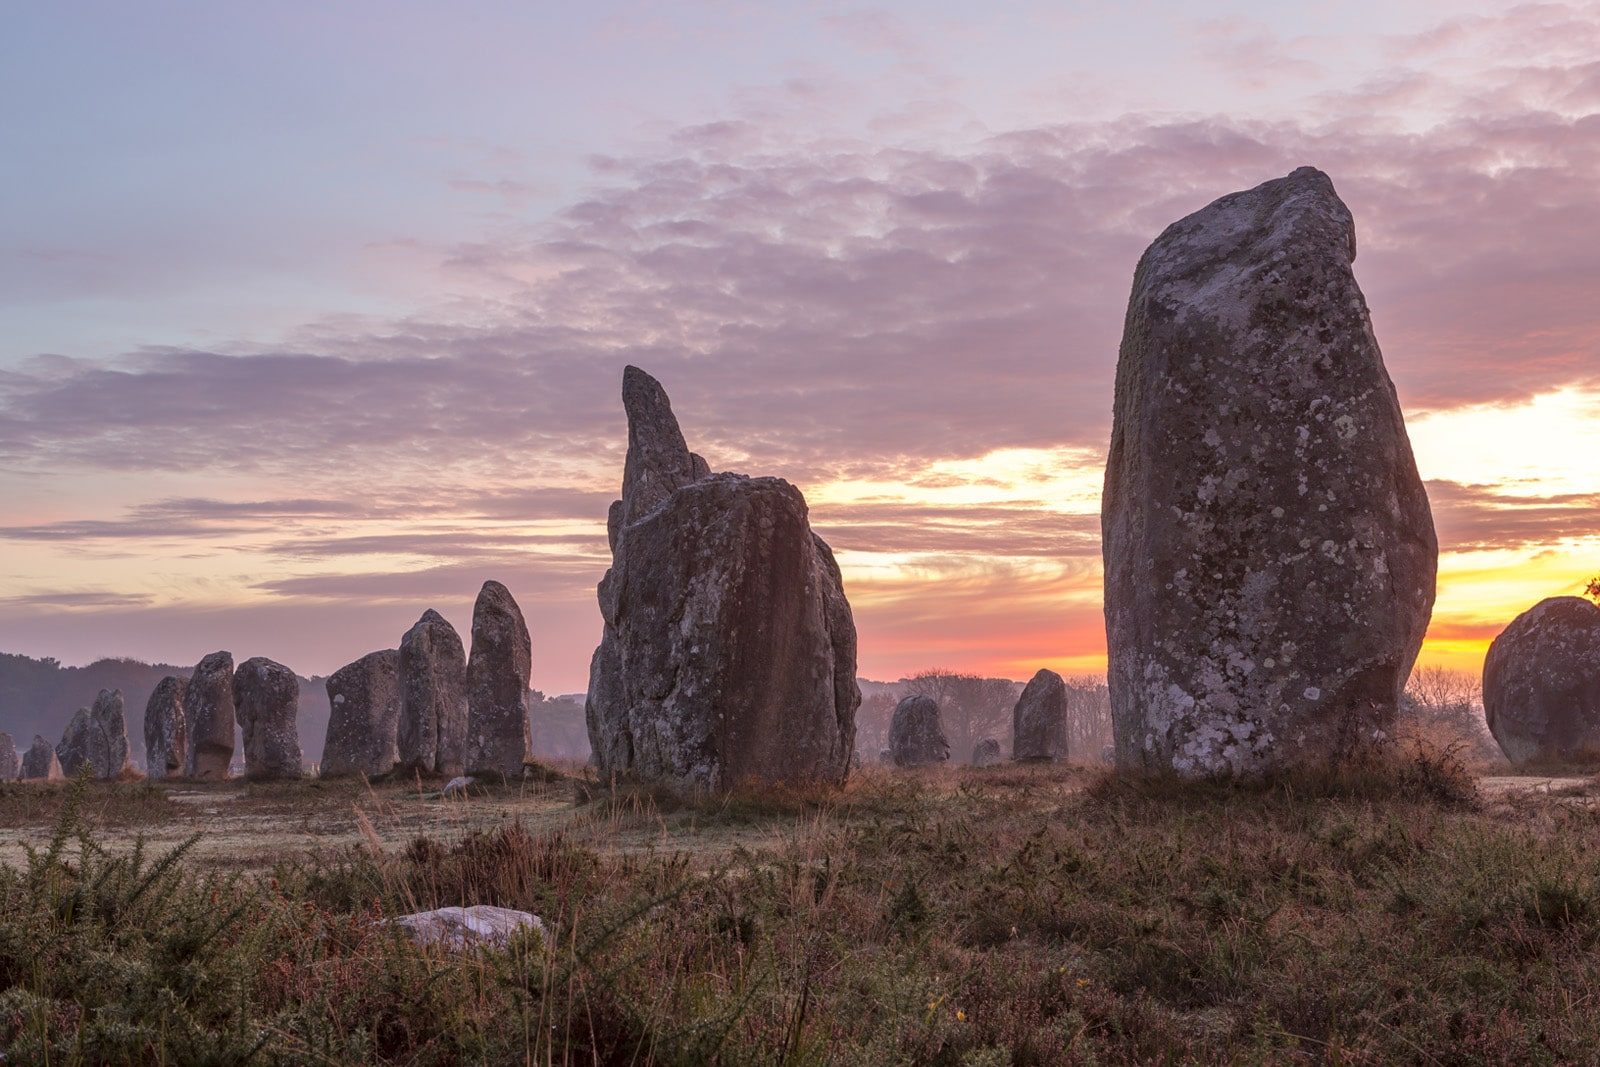Imagine this site being used for a modern-day event, what could it be? Imagine a magical evening where the Carnac stones transform into the backdrop for an ethereal music festival. As the sun sets, soft, ambient lighting illuminates the ancient megaliths, casting mystical shadows across the ground. Attendees, dressed in flowing, bohemian attire, gather together on blankets, the sound of acoustic guitars and ethereal vocals filling the air. In the center, a stage made of natural materials seamlessly blends with the surroundings, while projection mappings of swirling constellations dance across the stones. The festival highlights sustainability, with eco-friendly practices and organic food stalls. As the night deepens, a silent disco begins, headphones glowing in the darkness, creating a surreal, otherworldly experience as dancers move in synchronized harmony among the ancient stones. The event encapsulates a harmonious blend of the past and the future, promoting peace, community, and a deep respect for the Earth. What would be a more realistic modern-day use for this site? A more realistic modern-day use for the Carnac stones site could be educational tours and historical reenactments. The site would host guided tours led by archaeologists and historians, providing visitors with in-depth knowledge about the history, alignment, and significance of the stones. Educational workshops and interactive exhibits could be set up to engage young visitors and school groups, allowing them to learn about Neolithic life through hands-on activities. During certain times of the year, the site could also host historical reenactments, where actors in traditional attire recreate scenes from the lives of the people who built and used the stones. These activities not only educate but also bring history to life, offering a deeper connection to the past. 